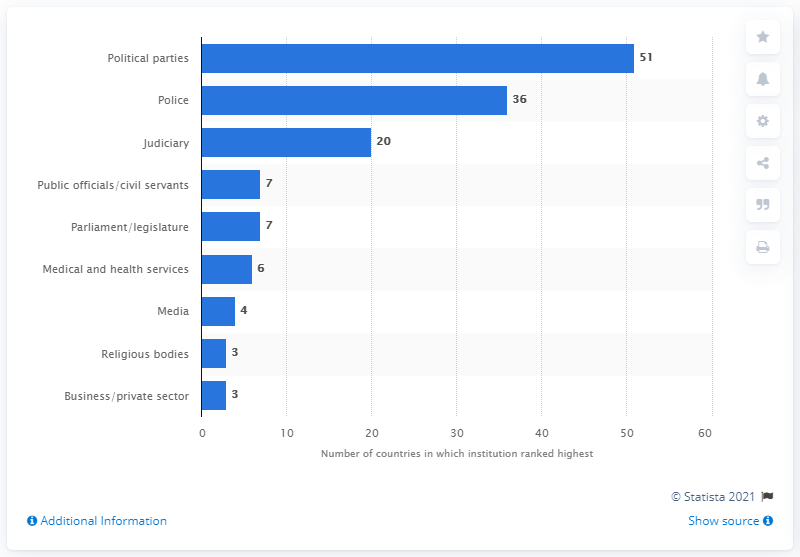Mention a couple of crucial points in this snapshot. In 2013, according to a survey of political parties, 51 countries reported that corruption was the most affected by political parties. 